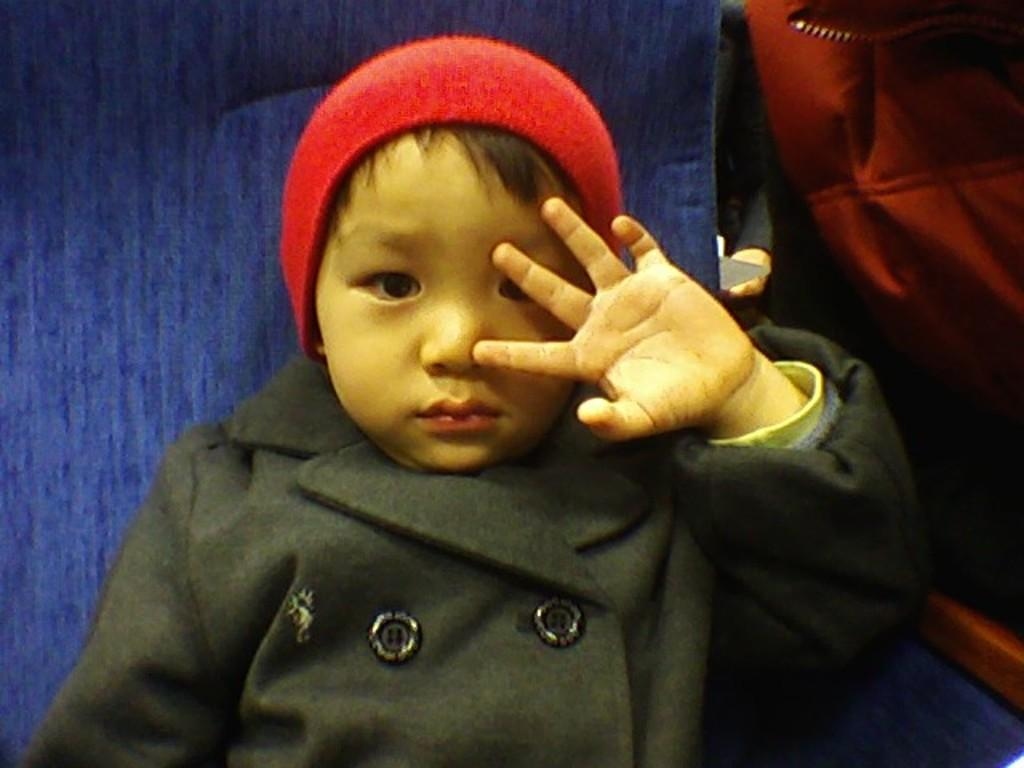Who is the main subject in the image? There is a boy in the image. What is the boy doing in the image? The boy is seated in a chair. What is the boy wearing on his head? The boy is wearing a red cap. What is the boy wearing on his upper body? The boy is wearing a black coat. What color is the chair the boy is sitting on? The chair is blue in color. How many pigs are visible in the image? There are no pigs present in the image. What type of coil is being used by the boy in the image? There is no coil visible in the image, and the boy is not using any coil. 